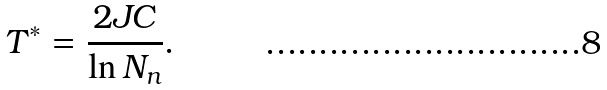Convert formula to latex. <formula><loc_0><loc_0><loc_500><loc_500>T ^ { * } = \frac { 2 J C } { \ln { N _ { n } } } .</formula> 